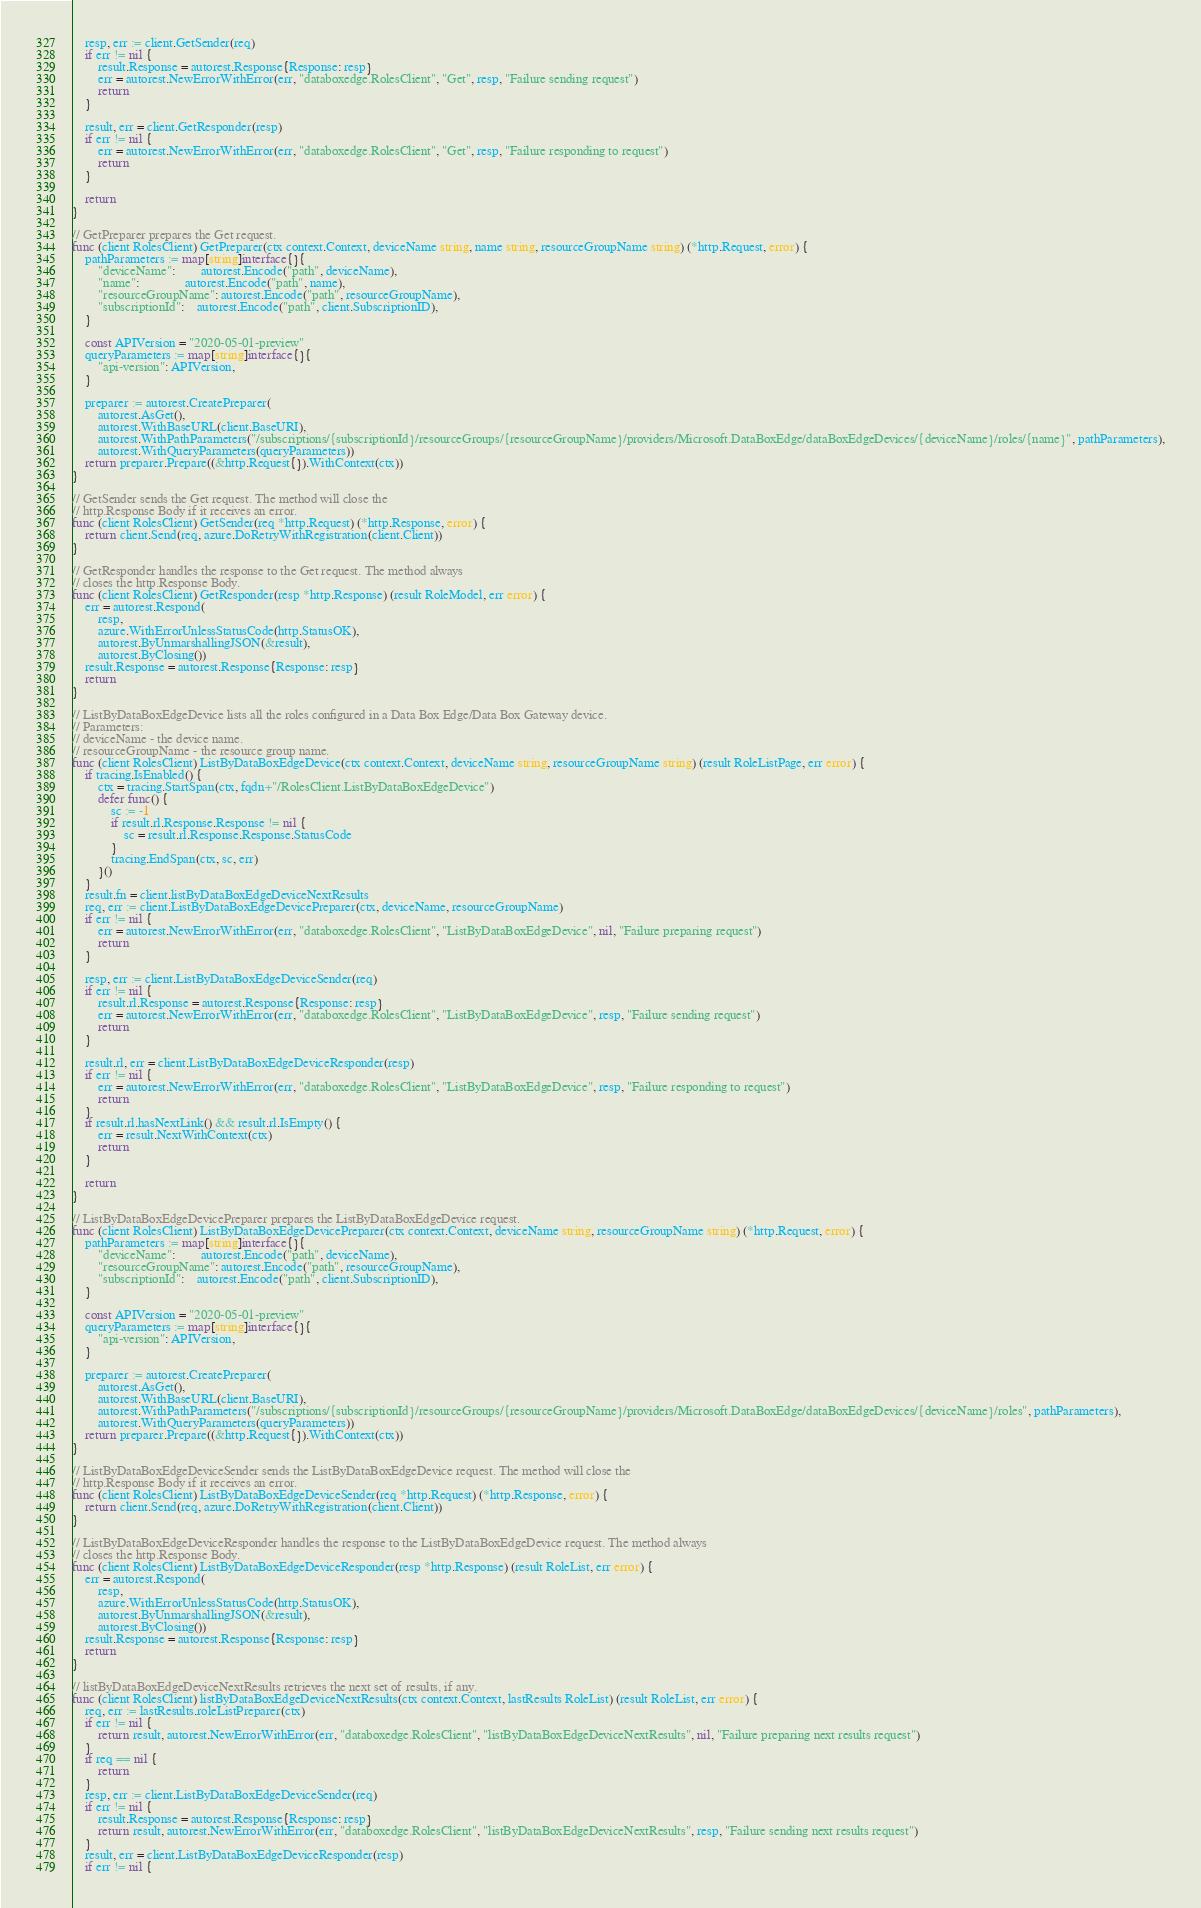Convert code to text. <code><loc_0><loc_0><loc_500><loc_500><_Go_>	resp, err := client.GetSender(req)
	if err != nil {
		result.Response = autorest.Response{Response: resp}
		err = autorest.NewErrorWithError(err, "databoxedge.RolesClient", "Get", resp, "Failure sending request")
		return
	}

	result, err = client.GetResponder(resp)
	if err != nil {
		err = autorest.NewErrorWithError(err, "databoxedge.RolesClient", "Get", resp, "Failure responding to request")
		return
	}

	return
}

// GetPreparer prepares the Get request.
func (client RolesClient) GetPreparer(ctx context.Context, deviceName string, name string, resourceGroupName string) (*http.Request, error) {
	pathParameters := map[string]interface{}{
		"deviceName":        autorest.Encode("path", deviceName),
		"name":              autorest.Encode("path", name),
		"resourceGroupName": autorest.Encode("path", resourceGroupName),
		"subscriptionId":    autorest.Encode("path", client.SubscriptionID),
	}

	const APIVersion = "2020-05-01-preview"
	queryParameters := map[string]interface{}{
		"api-version": APIVersion,
	}

	preparer := autorest.CreatePreparer(
		autorest.AsGet(),
		autorest.WithBaseURL(client.BaseURI),
		autorest.WithPathParameters("/subscriptions/{subscriptionId}/resourceGroups/{resourceGroupName}/providers/Microsoft.DataBoxEdge/dataBoxEdgeDevices/{deviceName}/roles/{name}", pathParameters),
		autorest.WithQueryParameters(queryParameters))
	return preparer.Prepare((&http.Request{}).WithContext(ctx))
}

// GetSender sends the Get request. The method will close the
// http.Response Body if it receives an error.
func (client RolesClient) GetSender(req *http.Request) (*http.Response, error) {
	return client.Send(req, azure.DoRetryWithRegistration(client.Client))
}

// GetResponder handles the response to the Get request. The method always
// closes the http.Response Body.
func (client RolesClient) GetResponder(resp *http.Response) (result RoleModel, err error) {
	err = autorest.Respond(
		resp,
		azure.WithErrorUnlessStatusCode(http.StatusOK),
		autorest.ByUnmarshallingJSON(&result),
		autorest.ByClosing())
	result.Response = autorest.Response{Response: resp}
	return
}

// ListByDataBoxEdgeDevice lists all the roles configured in a Data Box Edge/Data Box Gateway device.
// Parameters:
// deviceName - the device name.
// resourceGroupName - the resource group name.
func (client RolesClient) ListByDataBoxEdgeDevice(ctx context.Context, deviceName string, resourceGroupName string) (result RoleListPage, err error) {
	if tracing.IsEnabled() {
		ctx = tracing.StartSpan(ctx, fqdn+"/RolesClient.ListByDataBoxEdgeDevice")
		defer func() {
			sc := -1
			if result.rl.Response.Response != nil {
				sc = result.rl.Response.Response.StatusCode
			}
			tracing.EndSpan(ctx, sc, err)
		}()
	}
	result.fn = client.listByDataBoxEdgeDeviceNextResults
	req, err := client.ListByDataBoxEdgeDevicePreparer(ctx, deviceName, resourceGroupName)
	if err != nil {
		err = autorest.NewErrorWithError(err, "databoxedge.RolesClient", "ListByDataBoxEdgeDevice", nil, "Failure preparing request")
		return
	}

	resp, err := client.ListByDataBoxEdgeDeviceSender(req)
	if err != nil {
		result.rl.Response = autorest.Response{Response: resp}
		err = autorest.NewErrorWithError(err, "databoxedge.RolesClient", "ListByDataBoxEdgeDevice", resp, "Failure sending request")
		return
	}

	result.rl, err = client.ListByDataBoxEdgeDeviceResponder(resp)
	if err != nil {
		err = autorest.NewErrorWithError(err, "databoxedge.RolesClient", "ListByDataBoxEdgeDevice", resp, "Failure responding to request")
		return
	}
	if result.rl.hasNextLink() && result.rl.IsEmpty() {
		err = result.NextWithContext(ctx)
		return
	}

	return
}

// ListByDataBoxEdgeDevicePreparer prepares the ListByDataBoxEdgeDevice request.
func (client RolesClient) ListByDataBoxEdgeDevicePreparer(ctx context.Context, deviceName string, resourceGroupName string) (*http.Request, error) {
	pathParameters := map[string]interface{}{
		"deviceName":        autorest.Encode("path", deviceName),
		"resourceGroupName": autorest.Encode("path", resourceGroupName),
		"subscriptionId":    autorest.Encode("path", client.SubscriptionID),
	}

	const APIVersion = "2020-05-01-preview"
	queryParameters := map[string]interface{}{
		"api-version": APIVersion,
	}

	preparer := autorest.CreatePreparer(
		autorest.AsGet(),
		autorest.WithBaseURL(client.BaseURI),
		autorest.WithPathParameters("/subscriptions/{subscriptionId}/resourceGroups/{resourceGroupName}/providers/Microsoft.DataBoxEdge/dataBoxEdgeDevices/{deviceName}/roles", pathParameters),
		autorest.WithQueryParameters(queryParameters))
	return preparer.Prepare((&http.Request{}).WithContext(ctx))
}

// ListByDataBoxEdgeDeviceSender sends the ListByDataBoxEdgeDevice request. The method will close the
// http.Response Body if it receives an error.
func (client RolesClient) ListByDataBoxEdgeDeviceSender(req *http.Request) (*http.Response, error) {
	return client.Send(req, azure.DoRetryWithRegistration(client.Client))
}

// ListByDataBoxEdgeDeviceResponder handles the response to the ListByDataBoxEdgeDevice request. The method always
// closes the http.Response Body.
func (client RolesClient) ListByDataBoxEdgeDeviceResponder(resp *http.Response) (result RoleList, err error) {
	err = autorest.Respond(
		resp,
		azure.WithErrorUnlessStatusCode(http.StatusOK),
		autorest.ByUnmarshallingJSON(&result),
		autorest.ByClosing())
	result.Response = autorest.Response{Response: resp}
	return
}

// listByDataBoxEdgeDeviceNextResults retrieves the next set of results, if any.
func (client RolesClient) listByDataBoxEdgeDeviceNextResults(ctx context.Context, lastResults RoleList) (result RoleList, err error) {
	req, err := lastResults.roleListPreparer(ctx)
	if err != nil {
		return result, autorest.NewErrorWithError(err, "databoxedge.RolesClient", "listByDataBoxEdgeDeviceNextResults", nil, "Failure preparing next results request")
	}
	if req == nil {
		return
	}
	resp, err := client.ListByDataBoxEdgeDeviceSender(req)
	if err != nil {
		result.Response = autorest.Response{Response: resp}
		return result, autorest.NewErrorWithError(err, "databoxedge.RolesClient", "listByDataBoxEdgeDeviceNextResults", resp, "Failure sending next results request")
	}
	result, err = client.ListByDataBoxEdgeDeviceResponder(resp)
	if err != nil {</code> 